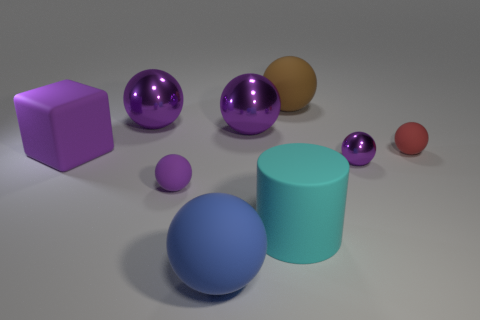There is a brown matte thing that is the same shape as the tiny purple matte thing; what is its size?
Ensure brevity in your answer.  Large. Is there a small purple ball that has the same material as the big blue sphere?
Provide a short and direct response. Yes. There is a purple object that is the same size as the purple matte ball; what material is it?
Make the answer very short. Metal. There is a tiny rubber thing to the left of the brown thing; does it have the same color as the shiny sphere in front of the small red sphere?
Make the answer very short. Yes. Is there a large brown rubber sphere that is in front of the metallic sphere that is to the right of the big rubber cylinder?
Keep it short and to the point. No. Does the large metallic thing that is right of the blue matte object have the same shape as the tiny object that is left of the big brown thing?
Make the answer very short. Yes. Does the purple object that is to the right of the brown rubber object have the same material as the large purple sphere that is to the left of the blue sphere?
Provide a short and direct response. Yes. There is a large purple ball that is to the right of the tiny ball that is to the left of the big brown ball; what is it made of?
Your response must be concise. Metal. There is a big purple metallic thing on the right side of the big matte ball in front of the tiny red object that is behind the blue object; what shape is it?
Provide a succinct answer. Sphere. What material is the brown thing that is the same shape as the blue matte object?
Your answer should be compact. Rubber. 